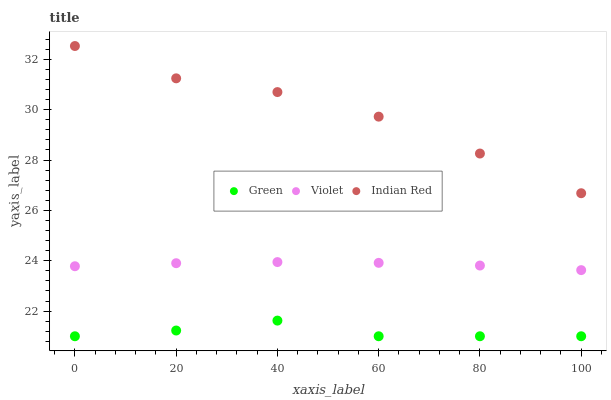Does Green have the minimum area under the curve?
Answer yes or no. Yes. Does Indian Red have the maximum area under the curve?
Answer yes or no. Yes. Does Violet have the minimum area under the curve?
Answer yes or no. No. Does Violet have the maximum area under the curve?
Answer yes or no. No. Is Violet the smoothest?
Answer yes or no. Yes. Is Green the roughest?
Answer yes or no. Yes. Is Indian Red the smoothest?
Answer yes or no. No. Is Indian Red the roughest?
Answer yes or no. No. Does Green have the lowest value?
Answer yes or no. Yes. Does Violet have the lowest value?
Answer yes or no. No. Does Indian Red have the highest value?
Answer yes or no. Yes. Does Violet have the highest value?
Answer yes or no. No. Is Violet less than Indian Red?
Answer yes or no. Yes. Is Violet greater than Green?
Answer yes or no. Yes. Does Violet intersect Indian Red?
Answer yes or no. No. 